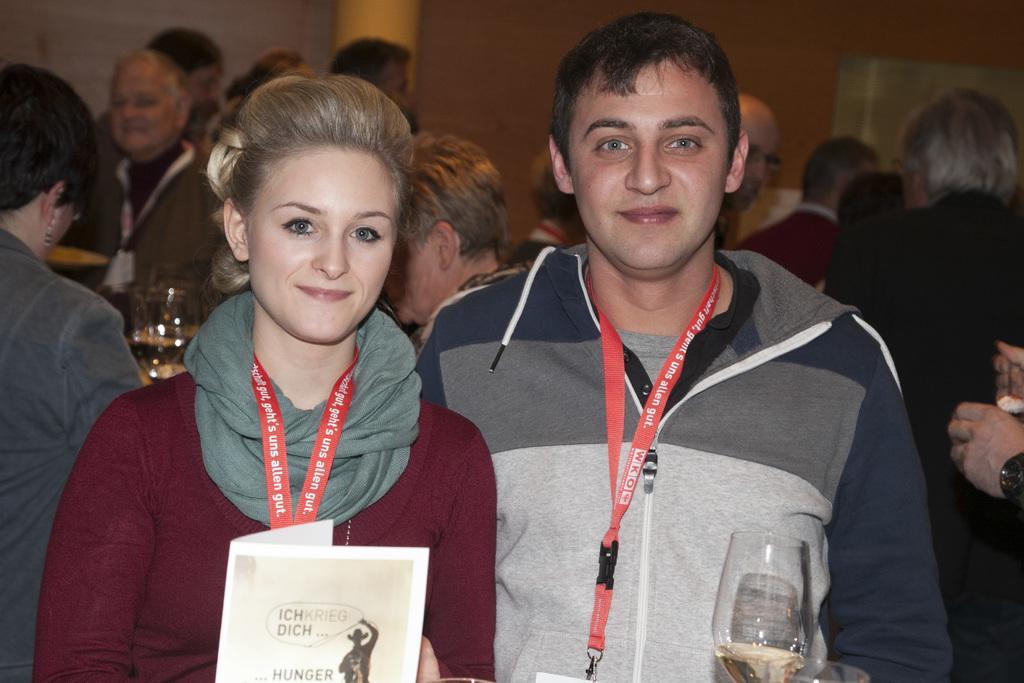In one or two sentences, can you explain what this image depicts? There are two members standing. The right side one is man and the left side one is woman. Both are having a tags and smiles on their faces. The woman is holding a paper and a man is holding a glass in his hands. Behind these two members there are many people standing. In the background we can observe wall and pillar 